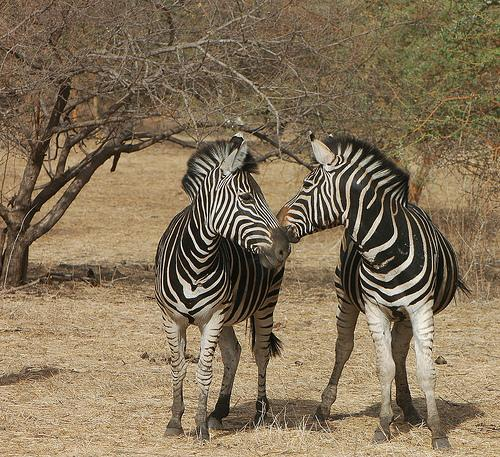Estimate the number of zebras present in the image and mention a key physical feature they share. There are two zebras, both have black and white stripes on their bodies. How does the ground appear in the image and what is its color? The ground appears dry and brown, with some burnt grass and dirt spots. Identify and describe a specific interaction between two objects or subjects in the image. Two zebras, positioned closely to one another, are nosing each other and playing in the field. What interesting phenomenon can be observed on the ground, influenced by the subjects and objects in the image? Shadows from the zebras and the tree can be seen cast on the ground. How many trees can be seen in the image and what is the condition of their leaves? Two trees can be seen; one has lost all its leaves and the other has green leaves in the distance. What interesting event is taking place with the primary subjects of this image? The zebras are engaging in play and nosing each other in the field. Which object is the tallest in the image and what is its condition? The tallest object is the tree on the left, which has lost all of its leaves. Explain the overall mood of the image based on the objects and environment present. The mood is lively and playful as two zebras interact in a savannah-like setting with trees and dry grass. Provide a concise description of the main objects in the image and their actions. Two zebras are playing near trees in a field with dry grass and visible shadows. Point out a unique characteristic that one of the zebras has on its face. One of the zebras has a small brown patch on its nose. 